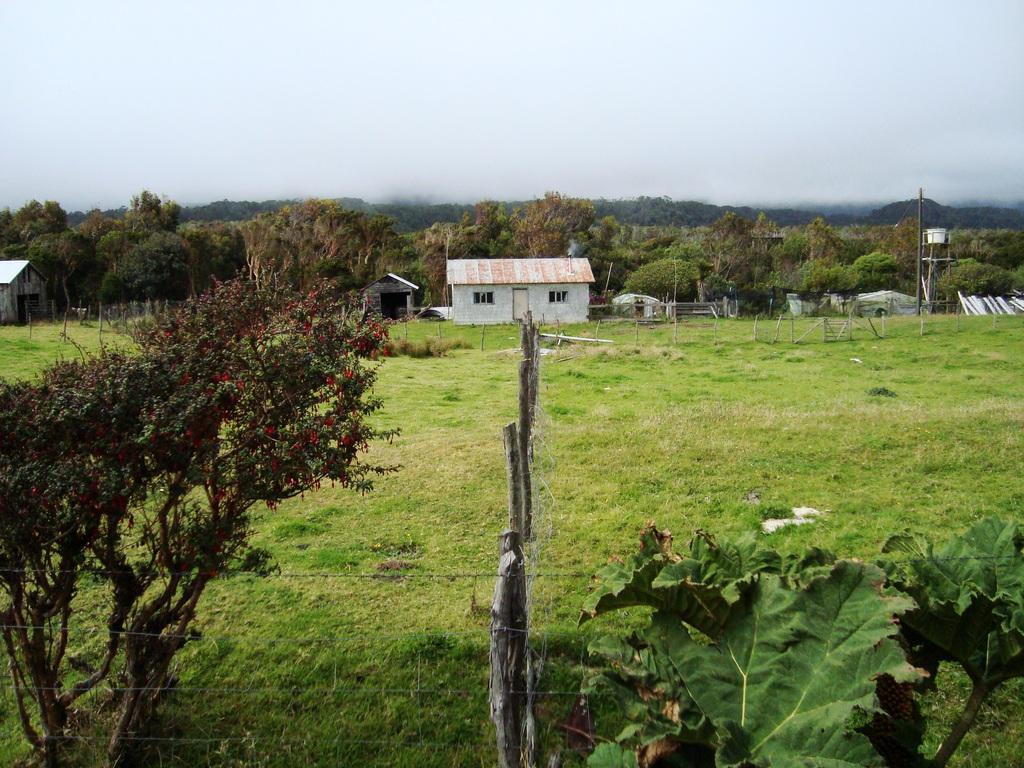Please provide a concise description of this image. In the picture I can see trees, houses, fence, the grass and poles. In the background I can see the sky. 